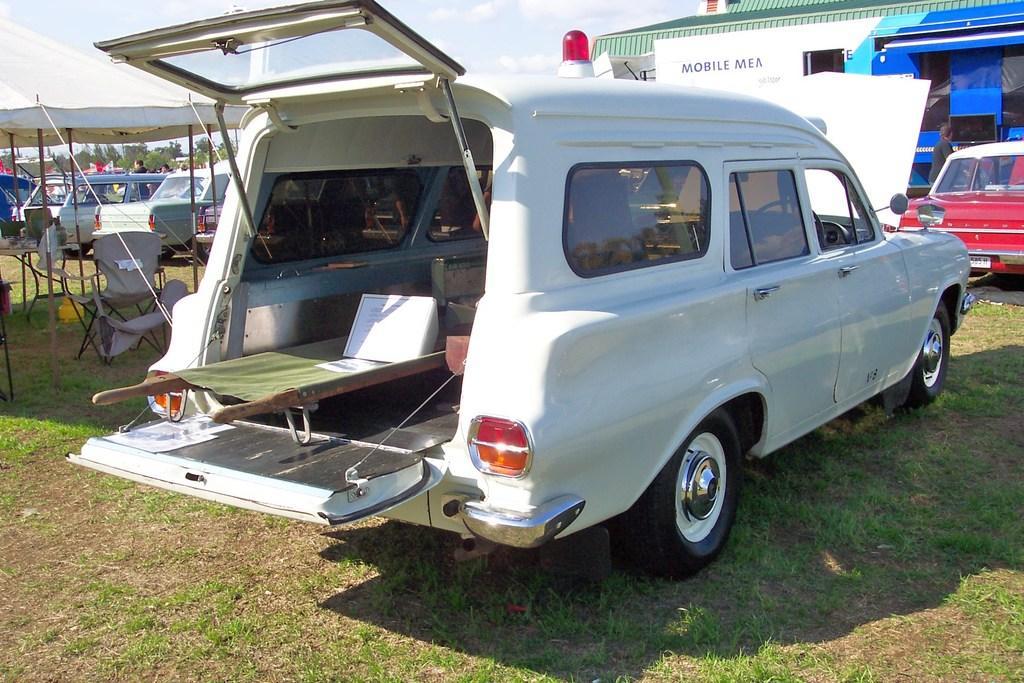Could you give a brief overview of what you see in this image? In this picture we can see vehicles, tent, chairs, rooftop and grass. In the background of the image there are people and we can see trees and sky with clouds. 